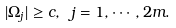Convert formula to latex. <formula><loc_0><loc_0><loc_500><loc_500>| \Omega _ { j } | \geq c , \ j = 1 , \cdots , 2 m .</formula> 